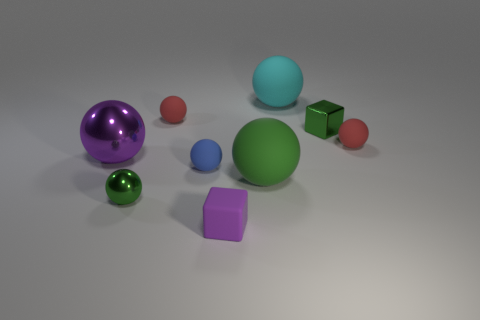Can you describe the shapes and colors present in this image? The image displays an assortment of geometric shapes on a plain surface. There are spheres, cubes, and a single cylinder. The colors include purple, green, red, blue, and teal. These elements are set against a neutral grey background, which accentuates the vividness of the colored objects. 